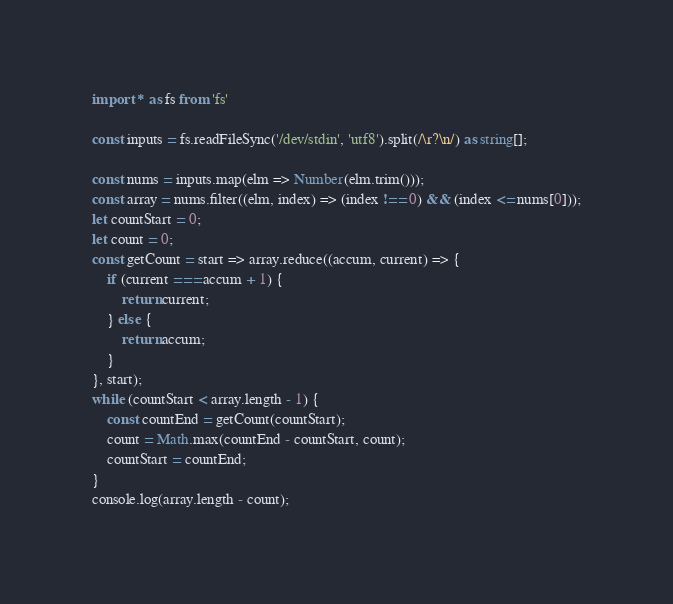Convert code to text. <code><loc_0><loc_0><loc_500><loc_500><_TypeScript_>import * as fs from 'fs'

const inputs = fs.readFileSync('/dev/stdin', 'utf8').split(/\r?\n/) as string[];

const nums = inputs.map(elm => Number(elm.trim()));
const array = nums.filter((elm, index) => (index !== 0) && (index <= nums[0]));
let countStart = 0;
let count = 0;
const getCount = start => array.reduce((accum, current) => {
    if (current === accum + 1) {
        return current;
    } else {
        return accum;
    }
}, start);
while (countStart < array.length - 1) {
    const countEnd = getCount(countStart);
    count = Math.max(countEnd - countStart, count);
    countStart = countEnd;
}
console.log(array.length - count);</code> 